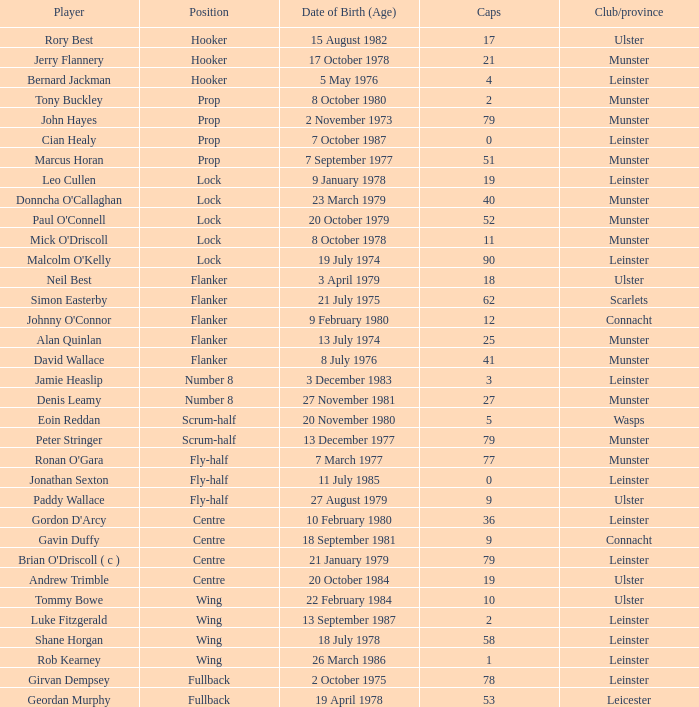What is the total of Caps when player born 13 December 1977? 79.0. 